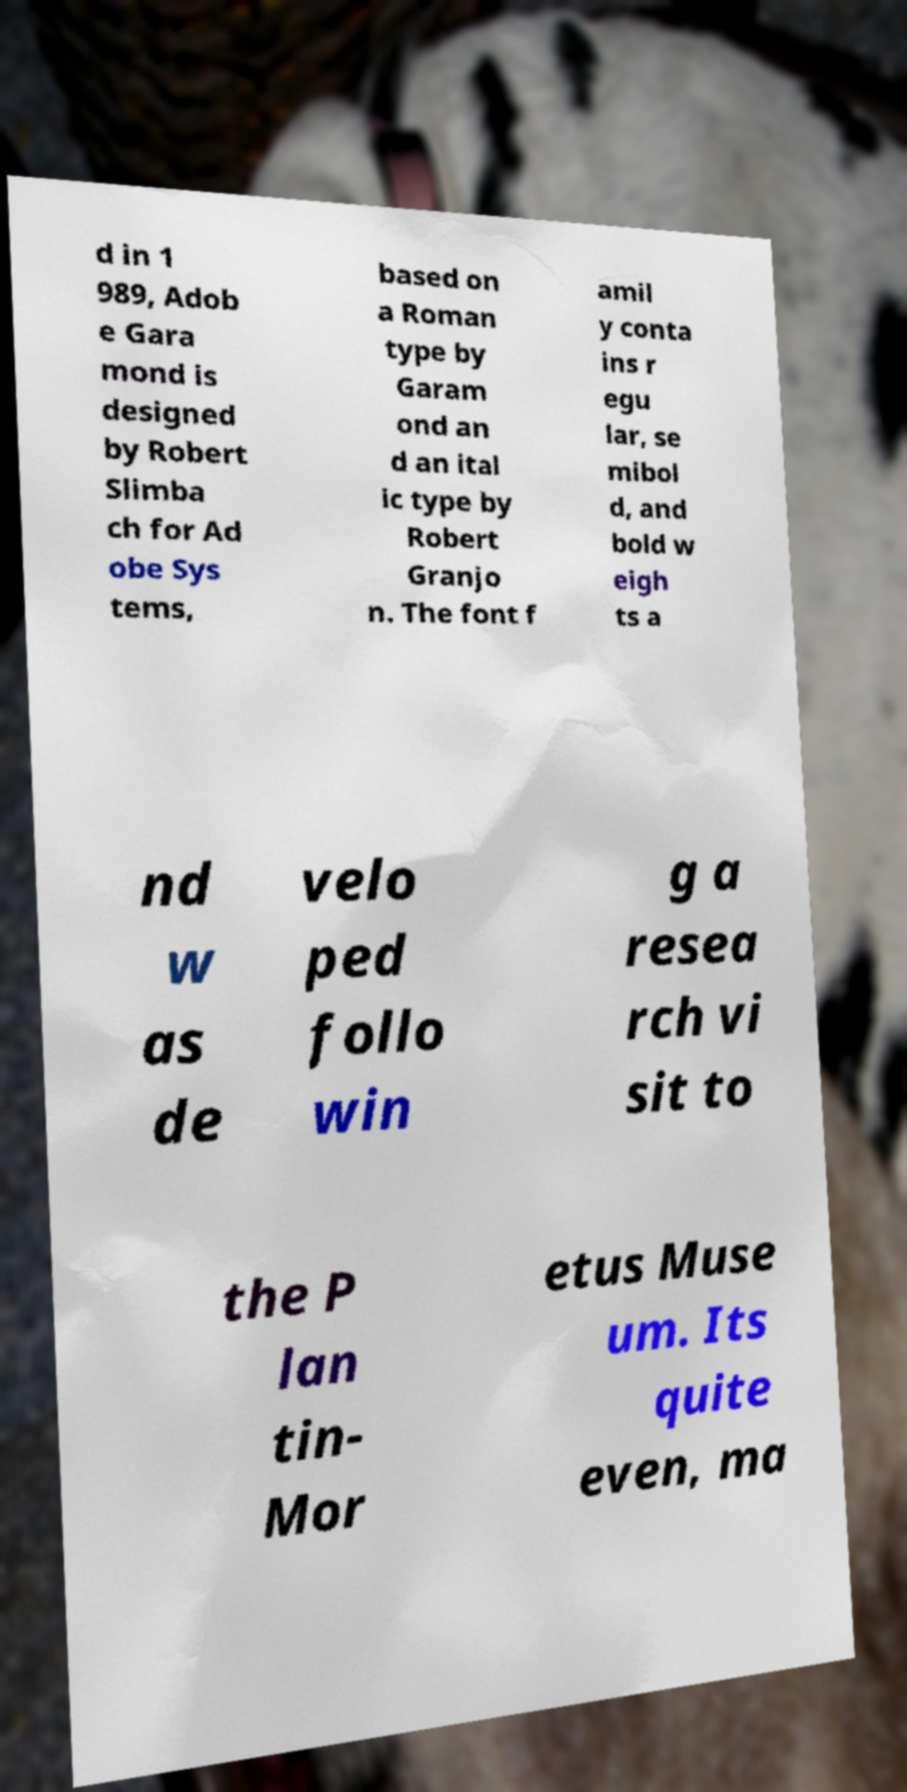Can you accurately transcribe the text from the provided image for me? d in 1 989, Adob e Gara mond is designed by Robert Slimba ch for Ad obe Sys tems, based on a Roman type by Garam ond an d an ital ic type by Robert Granjo n. The font f amil y conta ins r egu lar, se mibol d, and bold w eigh ts a nd w as de velo ped follo win g a resea rch vi sit to the P lan tin- Mor etus Muse um. Its quite even, ma 